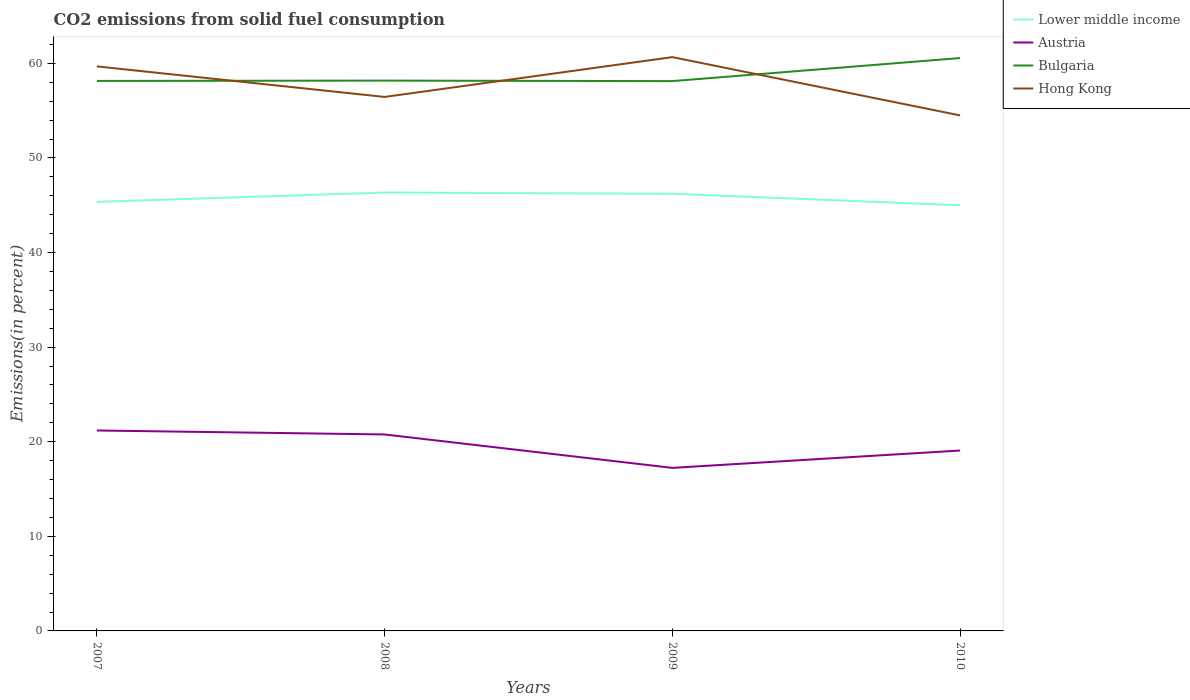Across all years, what is the maximum total CO2 emitted in Lower middle income?
Ensure brevity in your answer.  45. What is the total total CO2 emitted in Hong Kong in the graph?
Provide a short and direct response. -4.21. What is the difference between the highest and the second highest total CO2 emitted in Bulgaria?
Your response must be concise. 2.44. What is the difference between the highest and the lowest total CO2 emitted in Lower middle income?
Make the answer very short. 2. What is the difference between two consecutive major ticks on the Y-axis?
Offer a very short reply. 10. Are the values on the major ticks of Y-axis written in scientific E-notation?
Offer a terse response. No. Does the graph contain grids?
Provide a short and direct response. No. Where does the legend appear in the graph?
Make the answer very short. Top right. What is the title of the graph?
Give a very brief answer. CO2 emissions from solid fuel consumption. Does "Euro area" appear as one of the legend labels in the graph?
Your answer should be very brief. No. What is the label or title of the Y-axis?
Give a very brief answer. Emissions(in percent). What is the Emissions(in percent) in Lower middle income in 2007?
Offer a terse response. 45.36. What is the Emissions(in percent) of Austria in 2007?
Provide a short and direct response. 21.19. What is the Emissions(in percent) of Bulgaria in 2007?
Your response must be concise. 58.14. What is the Emissions(in percent) in Hong Kong in 2007?
Offer a very short reply. 59.68. What is the Emissions(in percent) of Lower middle income in 2008?
Keep it short and to the point. 46.35. What is the Emissions(in percent) of Austria in 2008?
Provide a short and direct response. 20.77. What is the Emissions(in percent) of Bulgaria in 2008?
Offer a very short reply. 58.18. What is the Emissions(in percent) of Hong Kong in 2008?
Your response must be concise. 56.45. What is the Emissions(in percent) in Lower middle income in 2009?
Offer a very short reply. 46.22. What is the Emissions(in percent) of Austria in 2009?
Ensure brevity in your answer.  17.24. What is the Emissions(in percent) of Bulgaria in 2009?
Offer a terse response. 58.12. What is the Emissions(in percent) in Hong Kong in 2009?
Offer a terse response. 60.66. What is the Emissions(in percent) of Lower middle income in 2010?
Make the answer very short. 45. What is the Emissions(in percent) of Austria in 2010?
Offer a terse response. 19.07. What is the Emissions(in percent) in Bulgaria in 2010?
Your response must be concise. 60.56. What is the Emissions(in percent) in Hong Kong in 2010?
Your answer should be compact. 54.5. Across all years, what is the maximum Emissions(in percent) of Lower middle income?
Provide a succinct answer. 46.35. Across all years, what is the maximum Emissions(in percent) in Austria?
Keep it short and to the point. 21.19. Across all years, what is the maximum Emissions(in percent) in Bulgaria?
Your response must be concise. 60.56. Across all years, what is the maximum Emissions(in percent) of Hong Kong?
Ensure brevity in your answer.  60.66. Across all years, what is the minimum Emissions(in percent) of Lower middle income?
Offer a terse response. 45. Across all years, what is the minimum Emissions(in percent) in Austria?
Ensure brevity in your answer.  17.24. Across all years, what is the minimum Emissions(in percent) in Bulgaria?
Keep it short and to the point. 58.12. Across all years, what is the minimum Emissions(in percent) in Hong Kong?
Provide a succinct answer. 54.5. What is the total Emissions(in percent) of Lower middle income in the graph?
Provide a succinct answer. 182.92. What is the total Emissions(in percent) in Austria in the graph?
Provide a succinct answer. 78.27. What is the total Emissions(in percent) of Bulgaria in the graph?
Your response must be concise. 235.01. What is the total Emissions(in percent) in Hong Kong in the graph?
Ensure brevity in your answer.  231.29. What is the difference between the Emissions(in percent) in Lower middle income in 2007 and that in 2008?
Your answer should be very brief. -0.99. What is the difference between the Emissions(in percent) in Austria in 2007 and that in 2008?
Keep it short and to the point. 0.42. What is the difference between the Emissions(in percent) in Bulgaria in 2007 and that in 2008?
Make the answer very short. -0.03. What is the difference between the Emissions(in percent) in Hong Kong in 2007 and that in 2008?
Offer a terse response. 3.23. What is the difference between the Emissions(in percent) of Lower middle income in 2007 and that in 2009?
Provide a short and direct response. -0.86. What is the difference between the Emissions(in percent) in Austria in 2007 and that in 2009?
Provide a succinct answer. 3.95. What is the difference between the Emissions(in percent) in Bulgaria in 2007 and that in 2009?
Ensure brevity in your answer.  0.02. What is the difference between the Emissions(in percent) of Hong Kong in 2007 and that in 2009?
Give a very brief answer. -0.98. What is the difference between the Emissions(in percent) in Lower middle income in 2007 and that in 2010?
Keep it short and to the point. 0.36. What is the difference between the Emissions(in percent) of Austria in 2007 and that in 2010?
Provide a succinct answer. 2.12. What is the difference between the Emissions(in percent) in Bulgaria in 2007 and that in 2010?
Make the answer very short. -2.42. What is the difference between the Emissions(in percent) of Hong Kong in 2007 and that in 2010?
Offer a very short reply. 5.18. What is the difference between the Emissions(in percent) in Lower middle income in 2008 and that in 2009?
Your response must be concise. 0.13. What is the difference between the Emissions(in percent) of Austria in 2008 and that in 2009?
Give a very brief answer. 3.53. What is the difference between the Emissions(in percent) in Bulgaria in 2008 and that in 2009?
Ensure brevity in your answer.  0.05. What is the difference between the Emissions(in percent) of Hong Kong in 2008 and that in 2009?
Provide a succinct answer. -4.21. What is the difference between the Emissions(in percent) of Lower middle income in 2008 and that in 2010?
Provide a succinct answer. 1.35. What is the difference between the Emissions(in percent) in Austria in 2008 and that in 2010?
Ensure brevity in your answer.  1.7. What is the difference between the Emissions(in percent) of Bulgaria in 2008 and that in 2010?
Provide a short and direct response. -2.39. What is the difference between the Emissions(in percent) of Hong Kong in 2008 and that in 2010?
Provide a short and direct response. 1.95. What is the difference between the Emissions(in percent) in Lower middle income in 2009 and that in 2010?
Provide a succinct answer. 1.22. What is the difference between the Emissions(in percent) of Austria in 2009 and that in 2010?
Make the answer very short. -1.83. What is the difference between the Emissions(in percent) in Bulgaria in 2009 and that in 2010?
Keep it short and to the point. -2.44. What is the difference between the Emissions(in percent) in Hong Kong in 2009 and that in 2010?
Offer a terse response. 6.16. What is the difference between the Emissions(in percent) in Lower middle income in 2007 and the Emissions(in percent) in Austria in 2008?
Ensure brevity in your answer.  24.59. What is the difference between the Emissions(in percent) in Lower middle income in 2007 and the Emissions(in percent) in Bulgaria in 2008?
Provide a succinct answer. -12.82. What is the difference between the Emissions(in percent) of Lower middle income in 2007 and the Emissions(in percent) of Hong Kong in 2008?
Offer a very short reply. -11.09. What is the difference between the Emissions(in percent) of Austria in 2007 and the Emissions(in percent) of Bulgaria in 2008?
Make the answer very short. -36.99. What is the difference between the Emissions(in percent) in Austria in 2007 and the Emissions(in percent) in Hong Kong in 2008?
Provide a short and direct response. -35.26. What is the difference between the Emissions(in percent) of Bulgaria in 2007 and the Emissions(in percent) of Hong Kong in 2008?
Give a very brief answer. 1.69. What is the difference between the Emissions(in percent) in Lower middle income in 2007 and the Emissions(in percent) in Austria in 2009?
Keep it short and to the point. 28.12. What is the difference between the Emissions(in percent) in Lower middle income in 2007 and the Emissions(in percent) in Bulgaria in 2009?
Ensure brevity in your answer.  -12.77. What is the difference between the Emissions(in percent) in Lower middle income in 2007 and the Emissions(in percent) in Hong Kong in 2009?
Ensure brevity in your answer.  -15.3. What is the difference between the Emissions(in percent) in Austria in 2007 and the Emissions(in percent) in Bulgaria in 2009?
Your answer should be compact. -36.93. What is the difference between the Emissions(in percent) of Austria in 2007 and the Emissions(in percent) of Hong Kong in 2009?
Offer a terse response. -39.47. What is the difference between the Emissions(in percent) of Bulgaria in 2007 and the Emissions(in percent) of Hong Kong in 2009?
Your response must be concise. -2.52. What is the difference between the Emissions(in percent) of Lower middle income in 2007 and the Emissions(in percent) of Austria in 2010?
Your answer should be compact. 26.29. What is the difference between the Emissions(in percent) of Lower middle income in 2007 and the Emissions(in percent) of Bulgaria in 2010?
Make the answer very short. -15.21. What is the difference between the Emissions(in percent) in Lower middle income in 2007 and the Emissions(in percent) in Hong Kong in 2010?
Offer a very short reply. -9.14. What is the difference between the Emissions(in percent) in Austria in 2007 and the Emissions(in percent) in Bulgaria in 2010?
Provide a short and direct response. -39.37. What is the difference between the Emissions(in percent) of Austria in 2007 and the Emissions(in percent) of Hong Kong in 2010?
Your response must be concise. -33.31. What is the difference between the Emissions(in percent) in Bulgaria in 2007 and the Emissions(in percent) in Hong Kong in 2010?
Keep it short and to the point. 3.65. What is the difference between the Emissions(in percent) of Lower middle income in 2008 and the Emissions(in percent) of Austria in 2009?
Offer a very short reply. 29.11. What is the difference between the Emissions(in percent) of Lower middle income in 2008 and the Emissions(in percent) of Bulgaria in 2009?
Keep it short and to the point. -11.78. What is the difference between the Emissions(in percent) of Lower middle income in 2008 and the Emissions(in percent) of Hong Kong in 2009?
Offer a terse response. -14.31. What is the difference between the Emissions(in percent) of Austria in 2008 and the Emissions(in percent) of Bulgaria in 2009?
Your answer should be very brief. -37.35. What is the difference between the Emissions(in percent) in Austria in 2008 and the Emissions(in percent) in Hong Kong in 2009?
Ensure brevity in your answer.  -39.89. What is the difference between the Emissions(in percent) of Bulgaria in 2008 and the Emissions(in percent) of Hong Kong in 2009?
Offer a terse response. -2.48. What is the difference between the Emissions(in percent) in Lower middle income in 2008 and the Emissions(in percent) in Austria in 2010?
Provide a short and direct response. 27.28. What is the difference between the Emissions(in percent) in Lower middle income in 2008 and the Emissions(in percent) in Bulgaria in 2010?
Offer a terse response. -14.21. What is the difference between the Emissions(in percent) in Lower middle income in 2008 and the Emissions(in percent) in Hong Kong in 2010?
Offer a terse response. -8.15. What is the difference between the Emissions(in percent) in Austria in 2008 and the Emissions(in percent) in Bulgaria in 2010?
Ensure brevity in your answer.  -39.79. What is the difference between the Emissions(in percent) in Austria in 2008 and the Emissions(in percent) in Hong Kong in 2010?
Your response must be concise. -33.73. What is the difference between the Emissions(in percent) of Bulgaria in 2008 and the Emissions(in percent) of Hong Kong in 2010?
Your answer should be very brief. 3.68. What is the difference between the Emissions(in percent) in Lower middle income in 2009 and the Emissions(in percent) in Austria in 2010?
Your response must be concise. 27.15. What is the difference between the Emissions(in percent) in Lower middle income in 2009 and the Emissions(in percent) in Bulgaria in 2010?
Your answer should be very brief. -14.35. What is the difference between the Emissions(in percent) in Lower middle income in 2009 and the Emissions(in percent) in Hong Kong in 2010?
Provide a succinct answer. -8.28. What is the difference between the Emissions(in percent) of Austria in 2009 and the Emissions(in percent) of Bulgaria in 2010?
Provide a succinct answer. -43.33. What is the difference between the Emissions(in percent) of Austria in 2009 and the Emissions(in percent) of Hong Kong in 2010?
Make the answer very short. -37.26. What is the difference between the Emissions(in percent) of Bulgaria in 2009 and the Emissions(in percent) of Hong Kong in 2010?
Your answer should be very brief. 3.63. What is the average Emissions(in percent) in Lower middle income per year?
Offer a terse response. 45.73. What is the average Emissions(in percent) in Austria per year?
Keep it short and to the point. 19.57. What is the average Emissions(in percent) in Bulgaria per year?
Provide a succinct answer. 58.75. What is the average Emissions(in percent) in Hong Kong per year?
Your answer should be very brief. 57.82. In the year 2007, what is the difference between the Emissions(in percent) in Lower middle income and Emissions(in percent) in Austria?
Keep it short and to the point. 24.17. In the year 2007, what is the difference between the Emissions(in percent) of Lower middle income and Emissions(in percent) of Bulgaria?
Offer a terse response. -12.79. In the year 2007, what is the difference between the Emissions(in percent) of Lower middle income and Emissions(in percent) of Hong Kong?
Make the answer very short. -14.32. In the year 2007, what is the difference between the Emissions(in percent) in Austria and Emissions(in percent) in Bulgaria?
Offer a terse response. -36.95. In the year 2007, what is the difference between the Emissions(in percent) of Austria and Emissions(in percent) of Hong Kong?
Your answer should be very brief. -38.49. In the year 2007, what is the difference between the Emissions(in percent) in Bulgaria and Emissions(in percent) in Hong Kong?
Ensure brevity in your answer.  -1.54. In the year 2008, what is the difference between the Emissions(in percent) in Lower middle income and Emissions(in percent) in Austria?
Your answer should be compact. 25.58. In the year 2008, what is the difference between the Emissions(in percent) in Lower middle income and Emissions(in percent) in Bulgaria?
Provide a succinct answer. -11.83. In the year 2008, what is the difference between the Emissions(in percent) in Lower middle income and Emissions(in percent) in Hong Kong?
Keep it short and to the point. -10.1. In the year 2008, what is the difference between the Emissions(in percent) of Austria and Emissions(in percent) of Bulgaria?
Your answer should be compact. -37.41. In the year 2008, what is the difference between the Emissions(in percent) of Austria and Emissions(in percent) of Hong Kong?
Your answer should be compact. -35.68. In the year 2008, what is the difference between the Emissions(in percent) of Bulgaria and Emissions(in percent) of Hong Kong?
Make the answer very short. 1.73. In the year 2009, what is the difference between the Emissions(in percent) in Lower middle income and Emissions(in percent) in Austria?
Your answer should be very brief. 28.98. In the year 2009, what is the difference between the Emissions(in percent) in Lower middle income and Emissions(in percent) in Bulgaria?
Your response must be concise. -11.91. In the year 2009, what is the difference between the Emissions(in percent) of Lower middle income and Emissions(in percent) of Hong Kong?
Offer a very short reply. -14.45. In the year 2009, what is the difference between the Emissions(in percent) in Austria and Emissions(in percent) in Bulgaria?
Your answer should be compact. -40.89. In the year 2009, what is the difference between the Emissions(in percent) of Austria and Emissions(in percent) of Hong Kong?
Ensure brevity in your answer.  -43.42. In the year 2009, what is the difference between the Emissions(in percent) of Bulgaria and Emissions(in percent) of Hong Kong?
Give a very brief answer. -2.54. In the year 2010, what is the difference between the Emissions(in percent) of Lower middle income and Emissions(in percent) of Austria?
Provide a succinct answer. 25.93. In the year 2010, what is the difference between the Emissions(in percent) of Lower middle income and Emissions(in percent) of Bulgaria?
Your response must be concise. -15.56. In the year 2010, what is the difference between the Emissions(in percent) in Lower middle income and Emissions(in percent) in Hong Kong?
Make the answer very short. -9.5. In the year 2010, what is the difference between the Emissions(in percent) of Austria and Emissions(in percent) of Bulgaria?
Keep it short and to the point. -41.49. In the year 2010, what is the difference between the Emissions(in percent) in Austria and Emissions(in percent) in Hong Kong?
Offer a very short reply. -35.43. In the year 2010, what is the difference between the Emissions(in percent) of Bulgaria and Emissions(in percent) of Hong Kong?
Make the answer very short. 6.07. What is the ratio of the Emissions(in percent) of Lower middle income in 2007 to that in 2008?
Provide a short and direct response. 0.98. What is the ratio of the Emissions(in percent) in Austria in 2007 to that in 2008?
Offer a terse response. 1.02. What is the ratio of the Emissions(in percent) in Bulgaria in 2007 to that in 2008?
Give a very brief answer. 1. What is the ratio of the Emissions(in percent) of Hong Kong in 2007 to that in 2008?
Provide a succinct answer. 1.06. What is the ratio of the Emissions(in percent) in Lower middle income in 2007 to that in 2009?
Your answer should be very brief. 0.98. What is the ratio of the Emissions(in percent) of Austria in 2007 to that in 2009?
Keep it short and to the point. 1.23. What is the ratio of the Emissions(in percent) of Hong Kong in 2007 to that in 2009?
Make the answer very short. 0.98. What is the ratio of the Emissions(in percent) of Austria in 2007 to that in 2010?
Provide a succinct answer. 1.11. What is the ratio of the Emissions(in percent) of Bulgaria in 2007 to that in 2010?
Your answer should be very brief. 0.96. What is the ratio of the Emissions(in percent) of Hong Kong in 2007 to that in 2010?
Offer a terse response. 1.1. What is the ratio of the Emissions(in percent) of Lower middle income in 2008 to that in 2009?
Your answer should be compact. 1. What is the ratio of the Emissions(in percent) of Austria in 2008 to that in 2009?
Offer a very short reply. 1.2. What is the ratio of the Emissions(in percent) of Bulgaria in 2008 to that in 2009?
Offer a terse response. 1. What is the ratio of the Emissions(in percent) in Hong Kong in 2008 to that in 2009?
Give a very brief answer. 0.93. What is the ratio of the Emissions(in percent) in Austria in 2008 to that in 2010?
Offer a very short reply. 1.09. What is the ratio of the Emissions(in percent) in Bulgaria in 2008 to that in 2010?
Your answer should be very brief. 0.96. What is the ratio of the Emissions(in percent) in Hong Kong in 2008 to that in 2010?
Offer a terse response. 1.04. What is the ratio of the Emissions(in percent) in Lower middle income in 2009 to that in 2010?
Your answer should be compact. 1.03. What is the ratio of the Emissions(in percent) of Austria in 2009 to that in 2010?
Give a very brief answer. 0.9. What is the ratio of the Emissions(in percent) in Bulgaria in 2009 to that in 2010?
Give a very brief answer. 0.96. What is the ratio of the Emissions(in percent) in Hong Kong in 2009 to that in 2010?
Offer a very short reply. 1.11. What is the difference between the highest and the second highest Emissions(in percent) of Lower middle income?
Ensure brevity in your answer.  0.13. What is the difference between the highest and the second highest Emissions(in percent) of Austria?
Keep it short and to the point. 0.42. What is the difference between the highest and the second highest Emissions(in percent) of Bulgaria?
Ensure brevity in your answer.  2.39. What is the difference between the highest and the second highest Emissions(in percent) of Hong Kong?
Provide a short and direct response. 0.98. What is the difference between the highest and the lowest Emissions(in percent) in Lower middle income?
Your answer should be very brief. 1.35. What is the difference between the highest and the lowest Emissions(in percent) in Austria?
Provide a succinct answer. 3.95. What is the difference between the highest and the lowest Emissions(in percent) of Bulgaria?
Ensure brevity in your answer.  2.44. What is the difference between the highest and the lowest Emissions(in percent) of Hong Kong?
Ensure brevity in your answer.  6.16. 